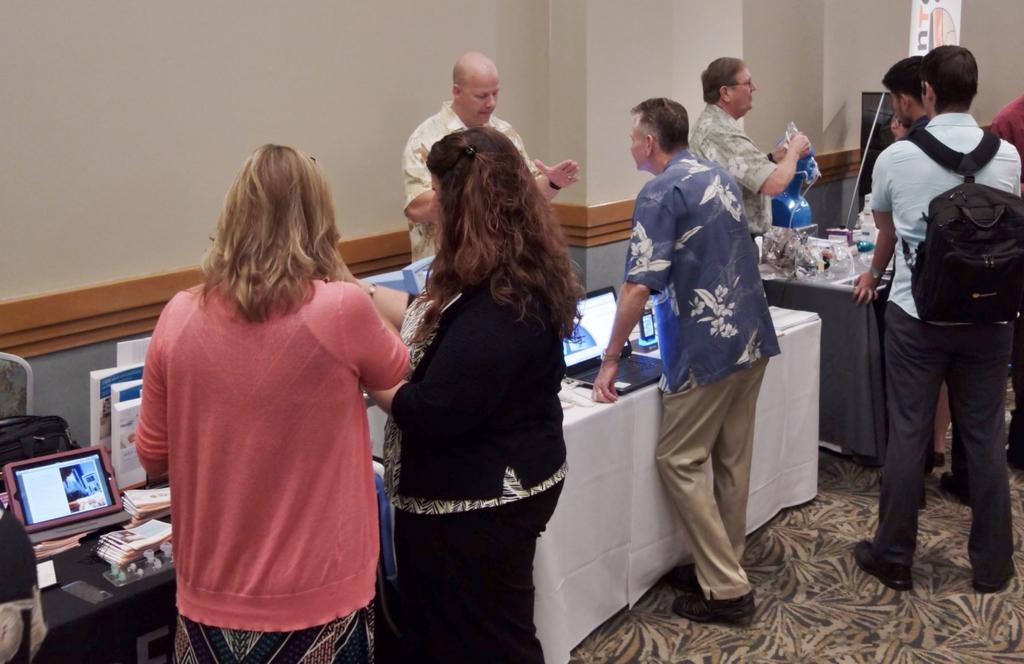Please provide a concise description of this image. In the image in the center we can see few people were standing around table. On table,we can see cloth,laptops,papers,phone and few other objects. In the background we can see wall,banner,chair,tap,books and few other objects. 